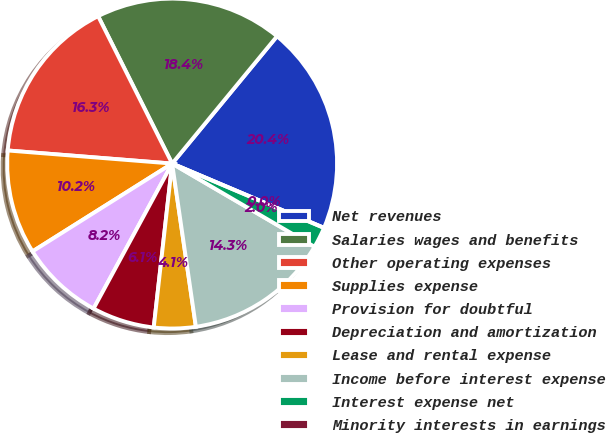<chart> <loc_0><loc_0><loc_500><loc_500><pie_chart><fcel>Net revenues<fcel>Salaries wages and benefits<fcel>Other operating expenses<fcel>Supplies expense<fcel>Provision for doubtful<fcel>Depreciation and amortization<fcel>Lease and rental expense<fcel>Income before interest expense<fcel>Interest expense net<fcel>Minority interests in earnings<nl><fcel>20.41%<fcel>18.37%<fcel>16.33%<fcel>10.2%<fcel>8.16%<fcel>6.12%<fcel>4.08%<fcel>14.28%<fcel>2.04%<fcel>0.0%<nl></chart> 